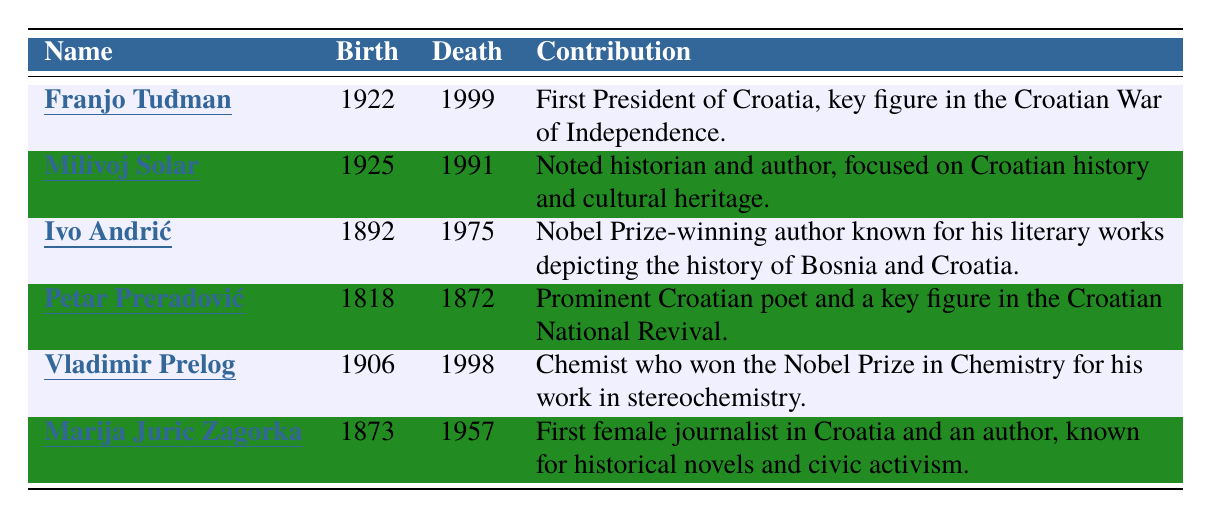What year was Franjo Tuđman born? Franjo Tuđman's birth year is listed in the table as 1922.
Answer: 1922 How many historical figures are listed in the table? The table contains 6 entries detailing historical figures.
Answer: 6 Who was the first female journalist in Croatia? According to the table, Marija Juric Zagorka is noted as the first female journalist in Croatia.
Answer: Marija Juric Zagorka Which figure won a Nobel Prize in Chemistry? The table indicates that Vladimir Prelog received the Nobel Prize in Chemistry.
Answer: Vladimir Prelog Between which years did Ivo Andrić live? Ivo Andrić's birth year is 1892 and his death year is 1975, meaning he lived from 1892 to 1975.
Answer: 1892 to 1975 What is the contribution of Milivoj Solar? Milivoj Solar is noted for being a historian and author who focused on Croatian history and cultural heritage.
Answer: Noted historian and author focused on Croatian history Which historical figure was born in the 19th century? Petar Preradović (born in 1818) and Marija Juric Zagorka (born in 1873) were both born in the 19th century.
Answer: Petar Preradović and Marija Juric Zagorka How many of the figures listed were Nobel Prize winners? There are 2 Nobel Prize winners listed: Ivo Andrić in literature and Vladimir Prelog in chemistry.
Answer: 2 What is the average birth year of the historical figures in the table? The birth years are: 1922, 1925, 1892, 1818, 1906, 1873. Their sum is 10936; dividing by 6 gives the average of 1822.67, rounded to 1823.
Answer: 1823 Is there any figure in the table who lived into the 21st century? Yes, Franjo Tuđman, who died in 1999, was the only figure who lived into the 21st century.
Answer: Yes Which contribution is associated with Petar Preradović? Petar Preradović is recognized as a prominent Croatian poet and a key figure in the Croatian National Revival.
Answer: Prominent Croatian poet and key figure in the Croatian National Revival 